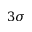<formula> <loc_0><loc_0><loc_500><loc_500>3 \sigma</formula> 